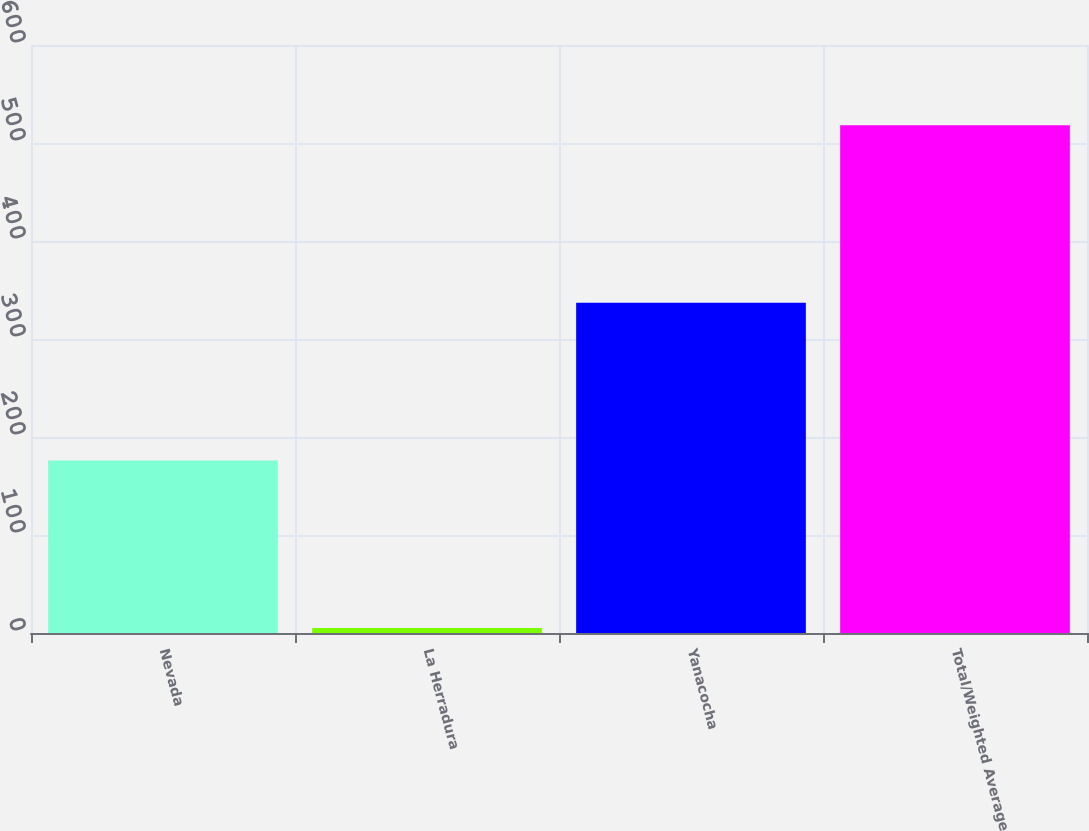Convert chart. <chart><loc_0><loc_0><loc_500><loc_500><bar_chart><fcel>Nevada<fcel>La Herradura<fcel>Yanacocha<fcel>Total/Weighted Average<nl><fcel>176<fcel>5<fcel>337<fcel>518<nl></chart> 